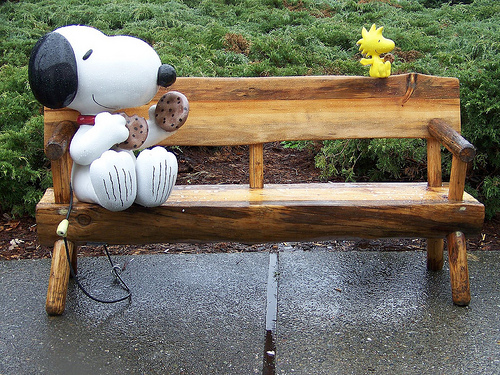<image>
Can you confirm if the snoopy is on the bench? Yes. Looking at the image, I can see the snoopy is positioned on top of the bench, with the bench providing support. Is there a bench next to the snoopy dog? Yes. The bench is positioned adjacent to the snoopy dog, located nearby in the same general area. Is there a snoopy next to the bench? No. The snoopy is not positioned next to the bench. They are located in different areas of the scene. 